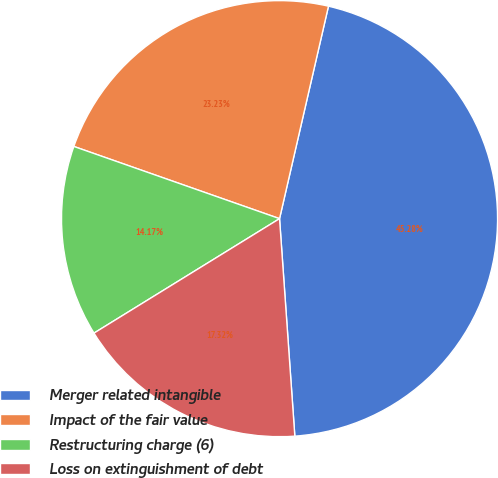Convert chart to OTSL. <chart><loc_0><loc_0><loc_500><loc_500><pie_chart><fcel>Merger related intangible<fcel>Impact of the fair value<fcel>Restructuring charge (6)<fcel>Loss on extinguishment of debt<nl><fcel>45.28%<fcel>23.23%<fcel>14.17%<fcel>17.32%<nl></chart> 